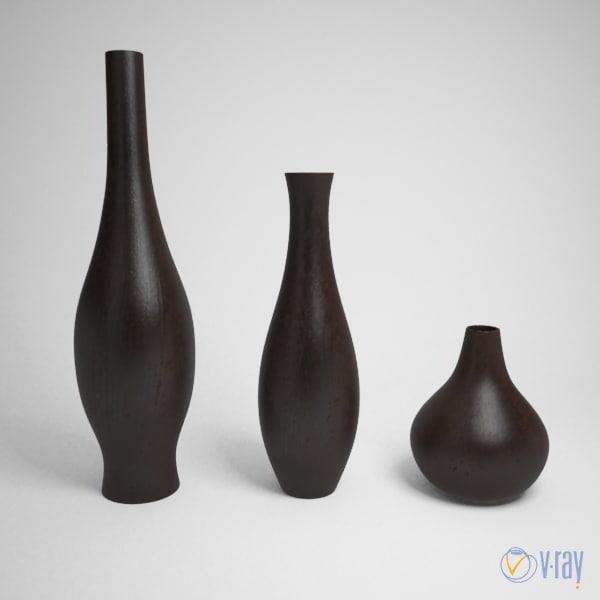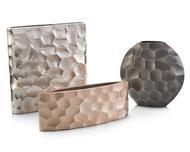The first image is the image on the left, the second image is the image on the right. Examine the images to the left and right. Is the description "there are dark fluted vases and hammered textured ones" accurate? Answer yes or no. Yes. 